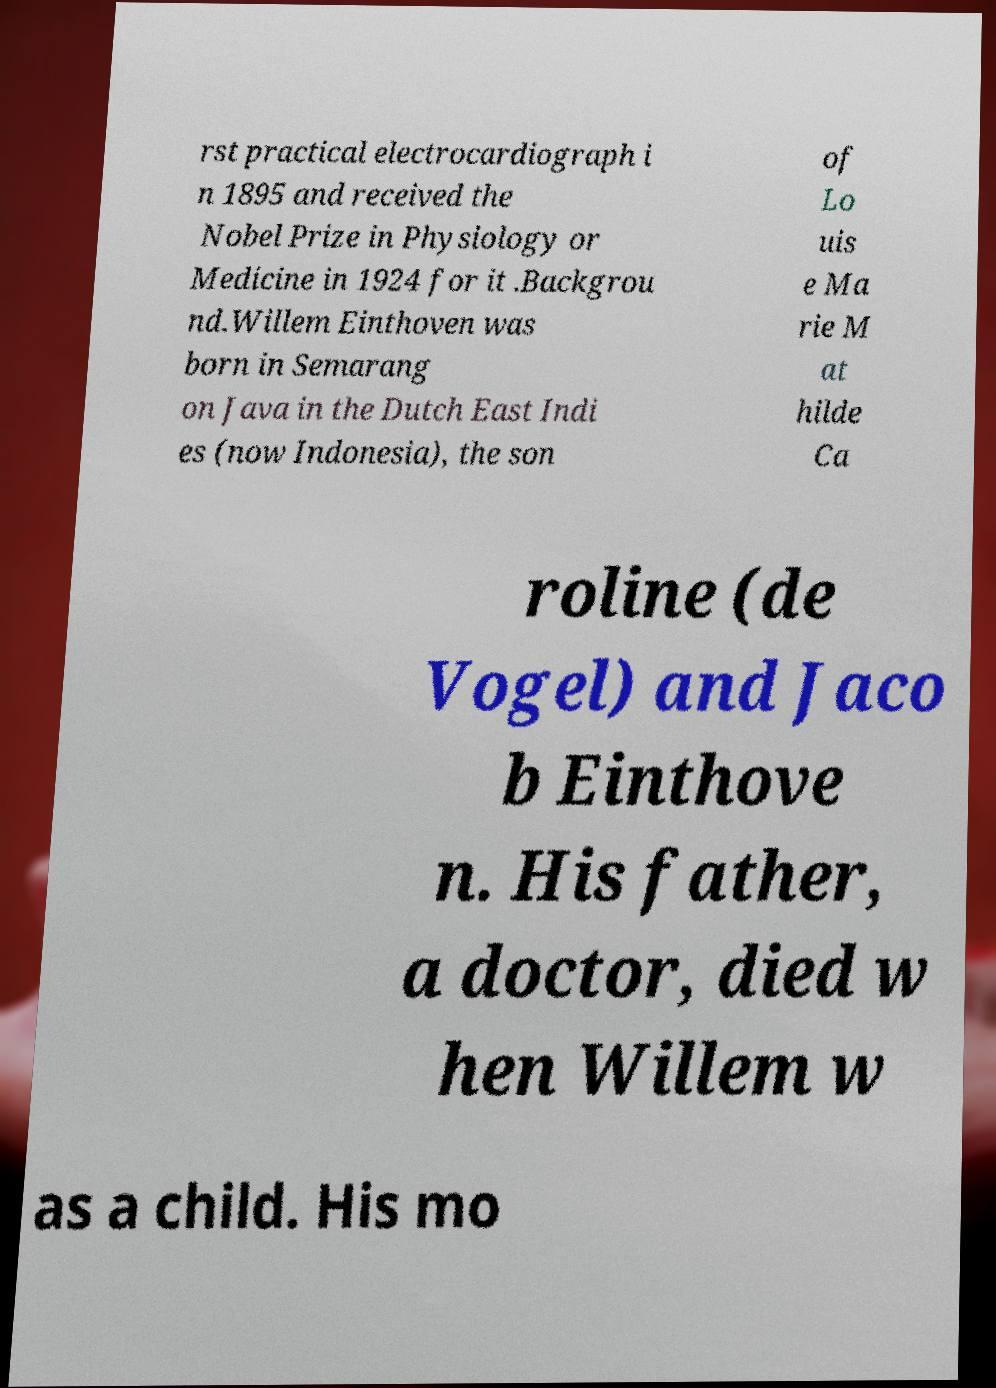Could you extract and type out the text from this image? rst practical electrocardiograph i n 1895 and received the Nobel Prize in Physiology or Medicine in 1924 for it .Backgrou nd.Willem Einthoven was born in Semarang on Java in the Dutch East Indi es (now Indonesia), the son of Lo uis e Ma rie M at hilde Ca roline (de Vogel) and Jaco b Einthove n. His father, a doctor, died w hen Willem w as a child. His mo 